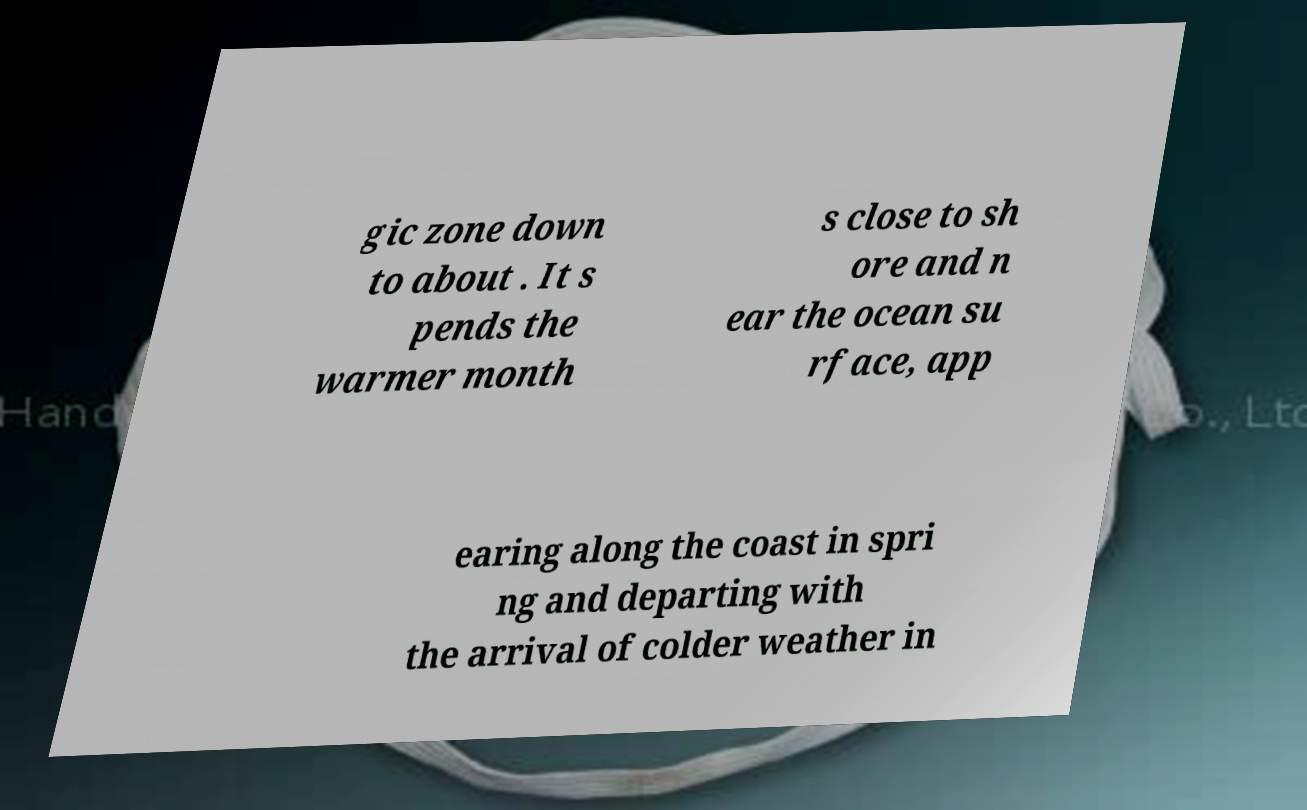Please read and relay the text visible in this image. What does it say? gic zone down to about . It s pends the warmer month s close to sh ore and n ear the ocean su rface, app earing along the coast in spri ng and departing with the arrival of colder weather in 